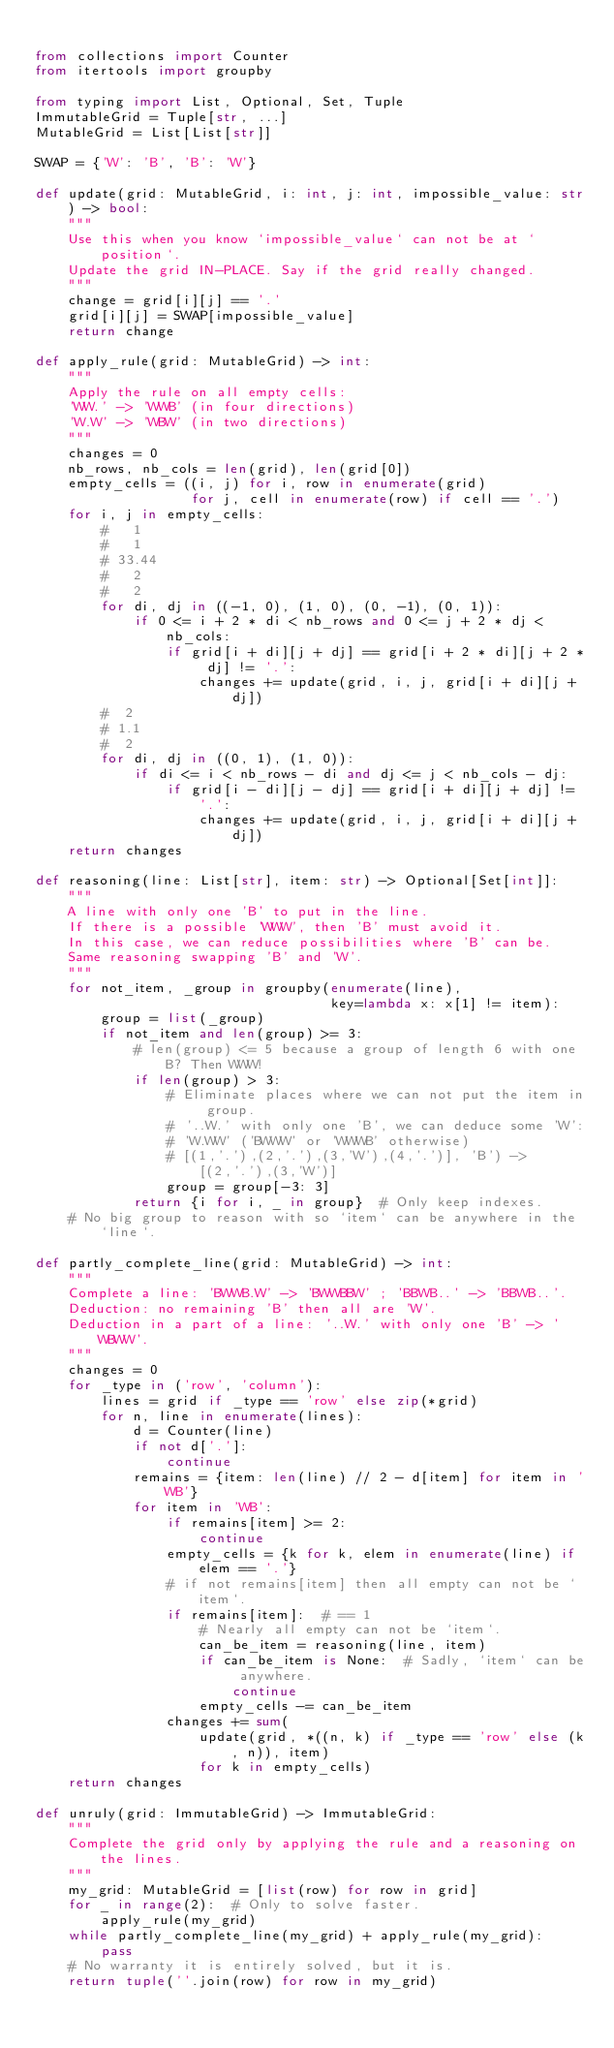Convert code to text. <code><loc_0><loc_0><loc_500><loc_500><_Python_>
from collections import Counter
from itertools import groupby

from typing import List, Optional, Set, Tuple
ImmutableGrid = Tuple[str, ...]
MutableGrid = List[List[str]]

SWAP = {'W': 'B', 'B': 'W'}

def update(grid: MutableGrid, i: int, j: int, impossible_value: str) -> bool:
    """
    Use this when you know `impossible_value` can not be at `position`.
    Update the grid IN-PLACE. Say if the grid really changed.
    """
    change = grid[i][j] == '.'
    grid[i][j] = SWAP[impossible_value]
    return change

def apply_rule(grid: MutableGrid) -> int:
    """
    Apply the rule on all empty cells:
    'WW.' -> 'WWB' (in four directions)
    'W.W' -> 'WBW' (in two directions)
    """
    changes = 0
    nb_rows, nb_cols = len(grid), len(grid[0])
    empty_cells = ((i, j) for i, row in enumerate(grid)
                   for j, cell in enumerate(row) if cell == '.')
    for i, j in empty_cells:
        #   1
        #   1
        # 33.44
        #   2
        #   2
        for di, dj in ((-1, 0), (1, 0), (0, -1), (0, 1)):
            if 0 <= i + 2 * di < nb_rows and 0 <= j + 2 * dj < nb_cols:
                if grid[i + di][j + dj] == grid[i + 2 * di][j + 2 * dj] != '.':
                    changes += update(grid, i, j, grid[i + di][j + dj])
        #  2
        # 1.1
        #  2
        for di, dj in ((0, 1), (1, 0)):
            if di <= i < nb_rows - di and dj <= j < nb_cols - dj:
                if grid[i - di][j - dj] == grid[i + di][j + dj] != '.':
                    changes += update(grid, i, j, grid[i + di][j + dj])
    return changes

def reasoning(line: List[str], item: str) -> Optional[Set[int]]:
    """
    A line with only one 'B' to put in the line.
    If there is a possible 'WWW', then 'B' must avoid it.
    In this case, we can reduce possibilities where 'B' can be.
    Same reasoning swapping 'B' and 'W'.
    """
    for not_item, _group in groupby(enumerate(line),
                                    key=lambda x: x[1] != item):
        group = list(_group)
        if not_item and len(group) >= 3:
            # len(group) <= 5 because a group of length 6 with one B? Then WWW!
            if len(group) > 3:
                # Eliminate places where we can not put the item in group.
                # '..W.' with only one 'B', we can deduce some 'W':
                # 'W.WW' ('BWWW' or 'WWWB' otherwise)
                # [(1,'.'),(2,'.'),(3,'W'),(4,'.')], 'B') -> [(2,'.'),(3,'W')]
                group = group[-3: 3]
            return {i for i, _ in group}  # Only keep indexes.
    # No big group to reason with so `item` can be anywhere in the `line`.

def partly_complete_line(grid: MutableGrid) -> int:
    """
    Complete a line: 'BWWB.W' -> 'BWWBBW' ; 'BBWB..' -> 'BBWB..'.
    Deduction: no remaining 'B' then all are 'W'.
    Deduction in a part of a line: '..W.' with only one 'B' -> 'WBWW'.
    """
    changes = 0
    for _type in ('row', 'column'):
        lines = grid if _type == 'row' else zip(*grid)
        for n, line in enumerate(lines):
            d = Counter(line)
            if not d['.']:
                continue
            remains = {item: len(line) // 2 - d[item] for item in 'WB'}
            for item in 'WB':
                if remains[item] >= 2:
                    continue
                empty_cells = {k for k, elem in enumerate(line) if elem == '.'}
                # if not remains[item] then all empty can not be `item`.
                if remains[item]:  # == 1
                    # Nearly all empty can not be `item`.
                    can_be_item = reasoning(line, item)
                    if can_be_item is None:  # Sadly, `item` can be anywhere.
                        continue
                    empty_cells -= can_be_item
                changes += sum(
                    update(grid, *((n, k) if _type == 'row' else (k, n)), item)
                    for k in empty_cells)
    return changes

def unruly(grid: ImmutableGrid) -> ImmutableGrid:
    """
    Complete the grid only by applying the rule and a reasoning on the lines.
    """
    my_grid: MutableGrid = [list(row) for row in grid]
    for _ in range(2):  # Only to solve faster.
        apply_rule(my_grid)
    while partly_complete_line(my_grid) + apply_rule(my_grid):
        pass
    # No warranty it is entirely solved, but it is.
    return tuple(''.join(row) for row in my_grid)
</code> 